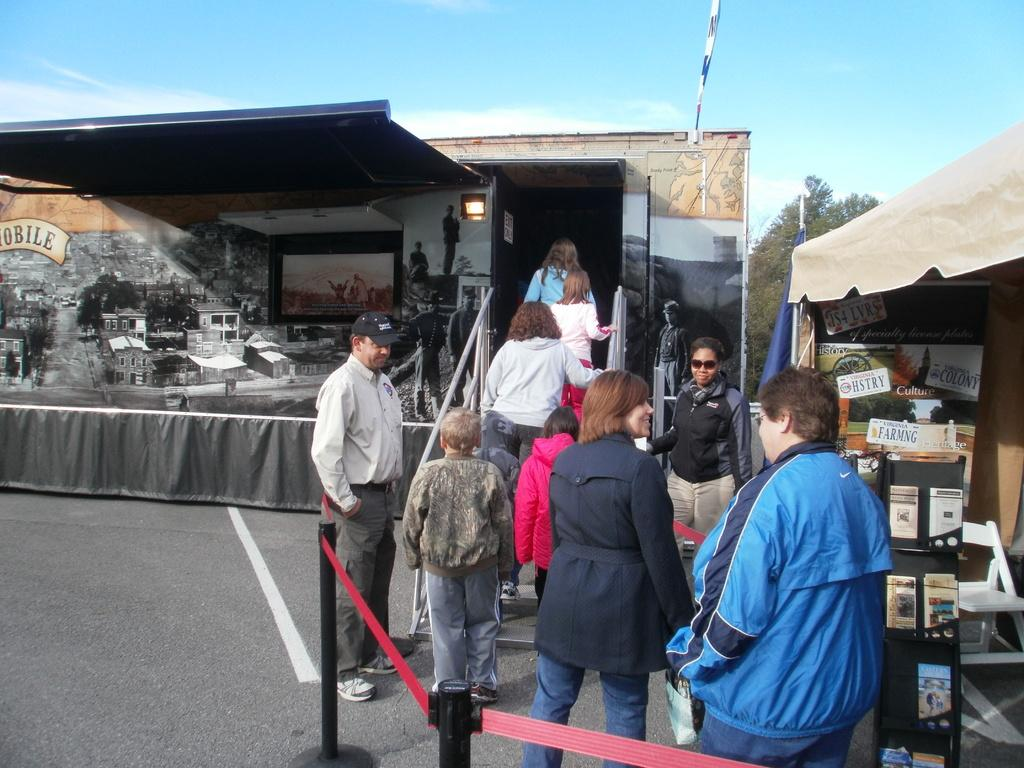<image>
Create a compact narrative representing the image presented. A store with people standing outside with one of the signs saying Farming. 